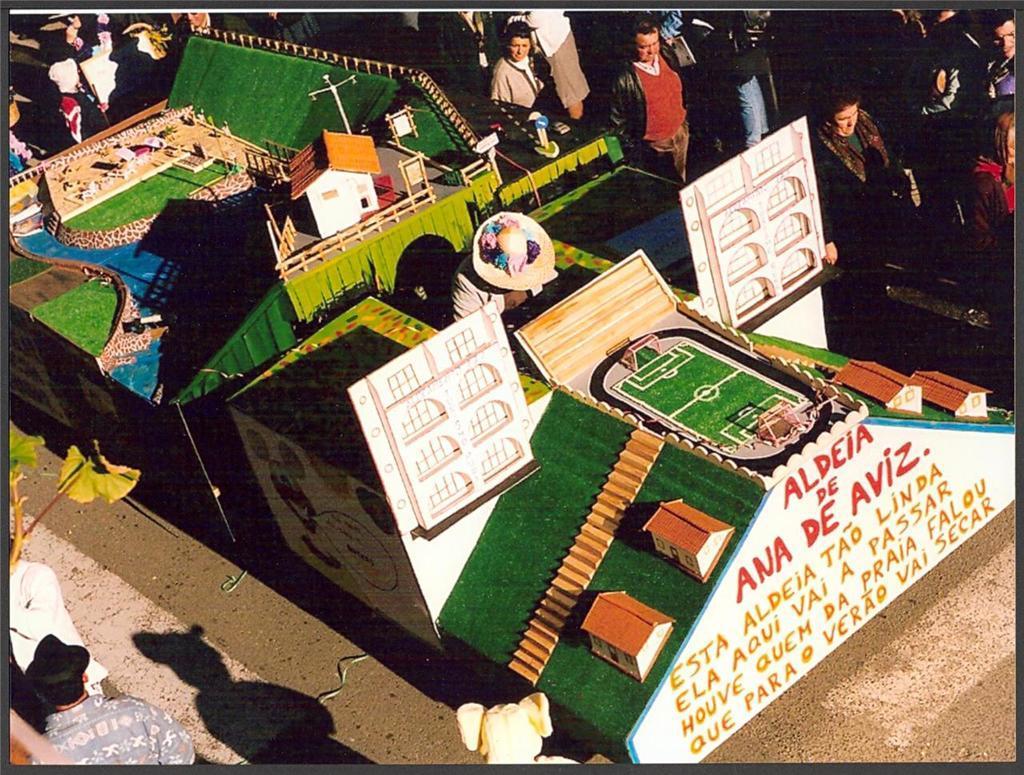In one or two sentences, can you explain what this image depicts? In this image I can see the miniature of few buildings, poles, fencing, boards and few objects. I can see few people around. 